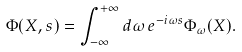<formula> <loc_0><loc_0><loc_500><loc_500>\Phi ( X , s ) = \int _ { - \infty } ^ { + \infty } d \omega \, e ^ { - i \omega s } \Phi _ { \omega } ( X ) .</formula> 